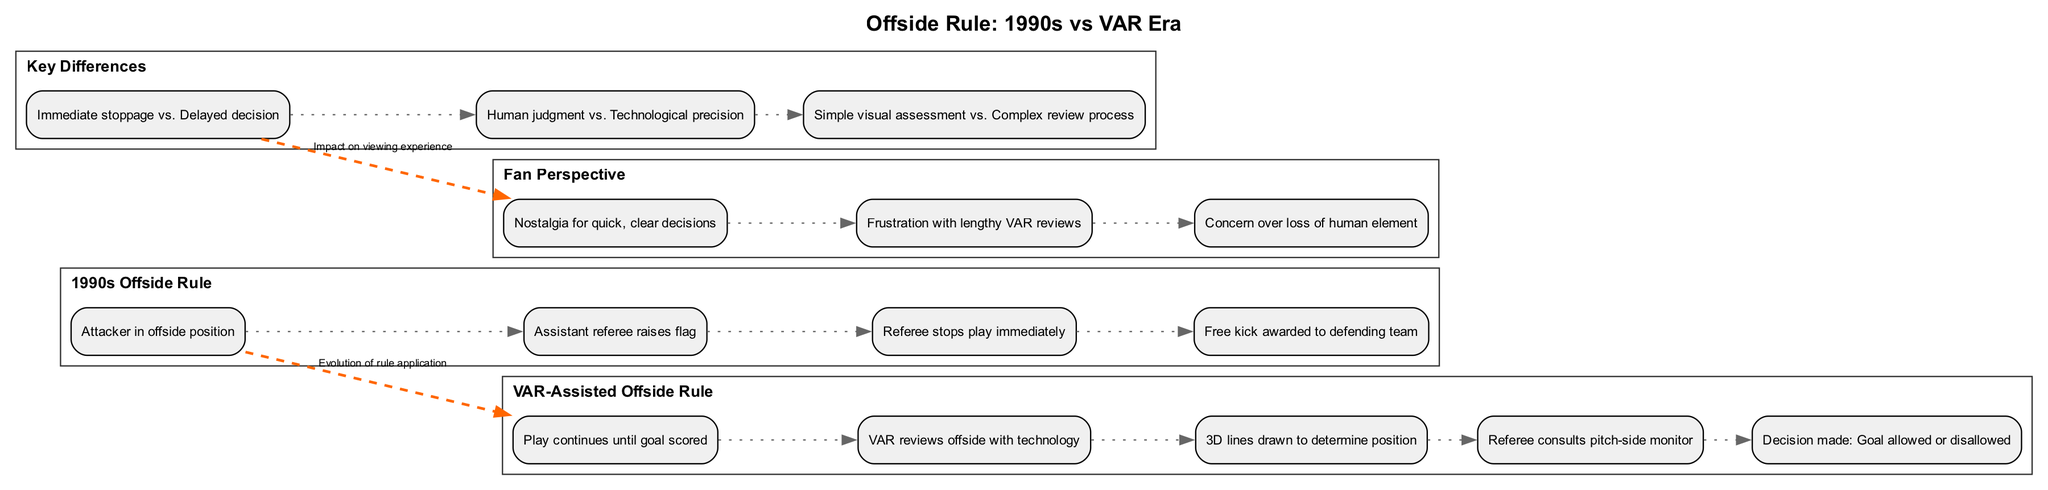What are the four elements of the 1990s Offside Rule? The diagram lists the elements under the "1990s Offside Rule" section. They include: "Attacker in offside position," "Assistant referee raises flag," "Referee stops play immediately," and "Free kick awarded to defending team."
Answer: Attacker in offside position, Assistant referee raises flag, Referee stops play immediately, Free kick awarded to defending team What technology is used in the VAR-assisted offside rule? The diagram indicates that the VAR-Assisted Offside Rule utilizes "3D lines drawn to determine position," showing the application of technology in the decision-making process.
Answer: 3D lines drawn to determine position What is one key difference between the 1990s Offside Rule and the VAR-Assisted Offside Rule? The "Key Differences" section outlines multiple differences. A specific difference is that the 1990s rule involved "Immediate stoppage," while the VAR Era has "Delayed decision."
Answer: Immediate stoppage vs. Delayed decision How does the fan perspective differ between the two eras? The diagram features a "Fan Perspective" section that reflects on nostalgia for quick decisions in the 1990s and frustration with lengthy VAR reviews, highlighting contrasting experiences for fans.
Answer: Nostalgia for quick, clear decisions Which section connects the 1990s Offside Rule to the VAR-Assisted Offside Rule? The diagram includes a connection labeled "Evolution of rule application" drawn from the 1990s Offside Rule section to the VAR-Assisted Offside Rule section, showing their relationship.
Answer: Evolution of rule application What key aspect does the "Fan Perspective" section mention regarding VAR? Within the "Fan Perspective" section, one of the key aspects mentioned is "Frustration with lengthy VAR reviews," indicating fans' concerns about the modern interpretation of the rule.
Answer: Frustration with lengthy VAR reviews How many elements are listed under the Key Differences? The "Key Differences" section in the diagram contains three distinct elements that highlight the differences between the two interpretations of the offside rule.
Answer: 3 